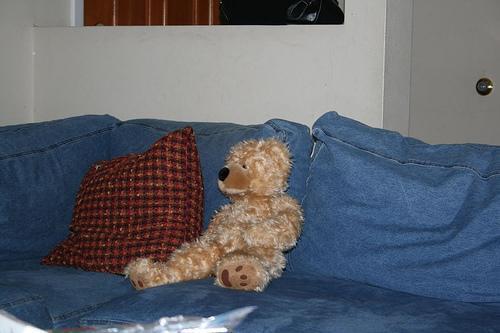How many personal sized pizzas are on the plate?
Give a very brief answer. 0. 